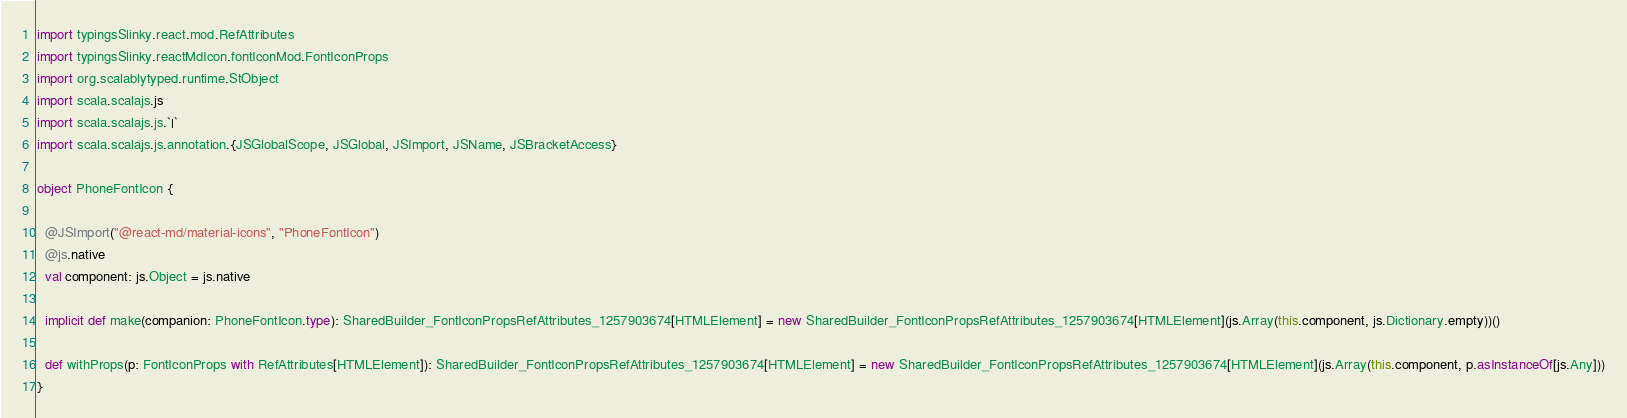Convert code to text. <code><loc_0><loc_0><loc_500><loc_500><_Scala_>import typingsSlinky.react.mod.RefAttributes
import typingsSlinky.reactMdIcon.fontIconMod.FontIconProps
import org.scalablytyped.runtime.StObject
import scala.scalajs.js
import scala.scalajs.js.`|`
import scala.scalajs.js.annotation.{JSGlobalScope, JSGlobal, JSImport, JSName, JSBracketAccess}

object PhoneFontIcon {
  
  @JSImport("@react-md/material-icons", "PhoneFontIcon")
  @js.native
  val component: js.Object = js.native
  
  implicit def make(companion: PhoneFontIcon.type): SharedBuilder_FontIconPropsRefAttributes_1257903674[HTMLElement] = new SharedBuilder_FontIconPropsRefAttributes_1257903674[HTMLElement](js.Array(this.component, js.Dictionary.empty))()
  
  def withProps(p: FontIconProps with RefAttributes[HTMLElement]): SharedBuilder_FontIconPropsRefAttributes_1257903674[HTMLElement] = new SharedBuilder_FontIconPropsRefAttributes_1257903674[HTMLElement](js.Array(this.component, p.asInstanceOf[js.Any]))
}
</code> 